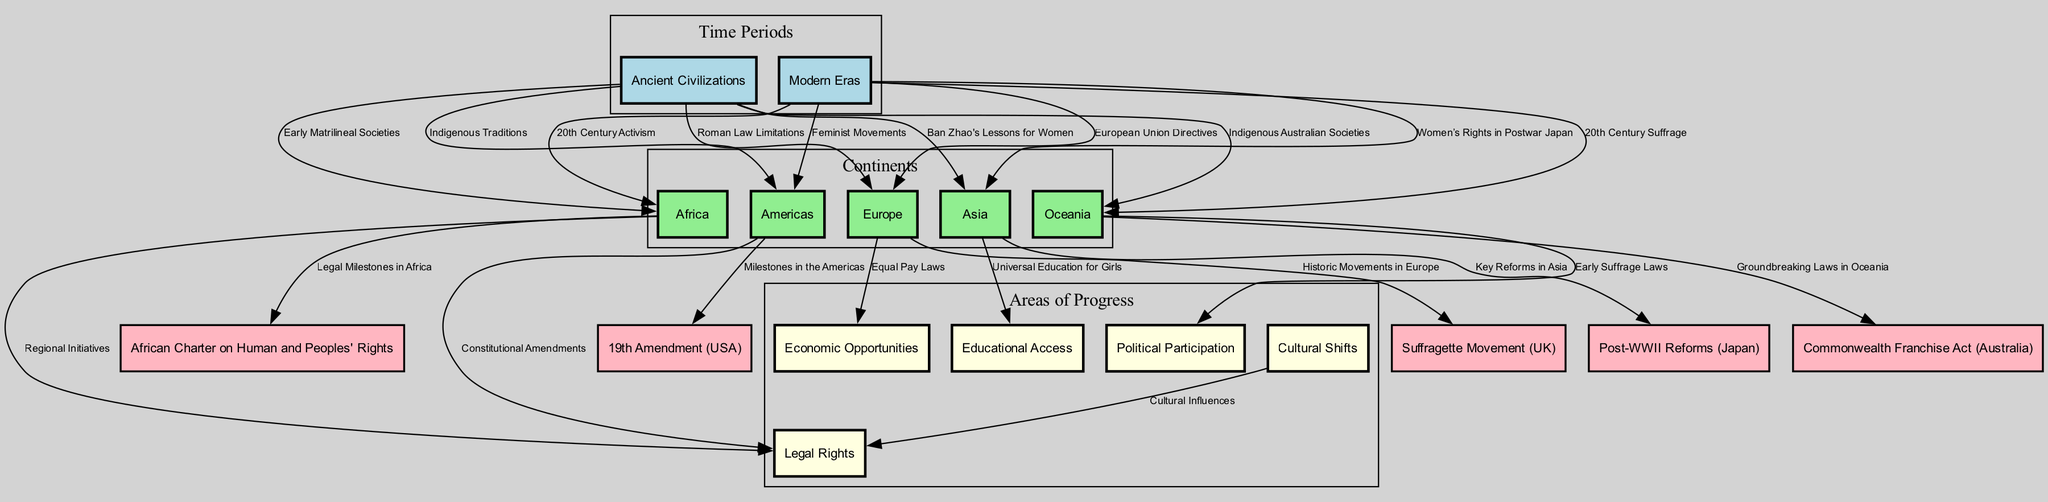What are the two time periods represented in the diagram? The diagram includes two time periods labeled as "Ancient Civilizations" and "Modern Eras," which are the primary nodes at the top of the diagram.
Answer: Ancient Civilizations, Modern Eras Which continent shows movements from ancient civilizations to modern eras? The edges indicate that all continents — Africa, Americas, Asia, Europe, and Oceania — have connections from the "Ancient Civilizations" node to the "Modern Eras" node, indicating a progression through time.
Answer: All continents How many edges are connected to the "Legal Rights" node? The diagram indicates that the "Legal Rights" node has three edges connecting it to different continents, specifically from Africa, Americas, and Cultural Shifts, indicating various movements that influenced legal rights.
Answer: 3 What is a significant source of cultural shifts impacting legal rights? The diagram shows an edge from "Cultural Shifts" to "Legal Rights," implying that cultural shifts play a significant role in influencing how legal rights evolve.
Answer: Cultural Shifts What milestone is connected to the Americas' modern progression of women's rights? The diagram indicates that the "19th Amendment (USA)" is a critical milestone in the progression of women's rights in the Americas, reflecting significant legal changes.
Answer: 19th Amendment (USA) What type of access is indicated for Asia in the modern era? The diagram shows that "Educational Access" is a point of progress in Asia as it connects with the node representing universal education for girls, highlighting educational advancements.
Answer: Educational Access Which continent has connections to early matrilineal societies? The edge from "Ancient Civilizations" to "Africa" indicates the link to early matrilineal societies, illustrating historical structures in African societies.
Answer: Africa What legislative act is connected to Oceania's modern era? The "Commonwealth Franchise Act (Australia)" is connected to Oceania as a significant legal advancement in women's rights during the modern era.
Answer: Commonwealth Franchise Act (Australia) 